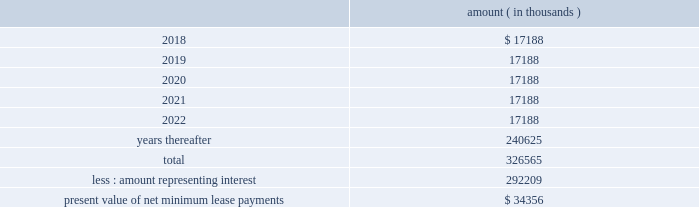As of december a031 , 2017 , system energy , in connection with the grand gulf sale and leaseback transactions , had future minimum lease payments ( reflecting an implicit rate of 5.13% ( 5.13 % ) ) that are recorded as long-term debt , as follows : amount ( in thousands ) .
Entergy corporation and subsidiaries notes to financial statements note 11 . a0 retirement , other postretirement benefits , and defined contribution plans a0 a0 ( entergy corporation , entergy arkansas , entergy louisiana , entergy mississippi , entergy new orleans , entergy texas , and system energy ) qualified pension plans entergy has eight qualified pension plans covering substantially all employees .
The entergy corporation retirement plan for non-bargaining employees ( non-bargaining plan i ) , the entergy corporation retirement plan for bargaining employees ( bargaining plan i ) , the entergy corporation retirement plan ii for non-bargaining employees ( non-bargaining plan ii ) , the entergy corporation retirement plan ii for bargaining employees , the entergy corporation retirement plan iii , and the entergy corporation retirement plan iv for bargaining employees a0are non-contributory final average pay plans and provide pension benefits that are based on employees 2019 credited service and compensation during employment .
Effective as of the close of business on december 31 , 2016 , the entergy corporation retirement plan iv for non-bargaining employees ( non-bargaining plan iv ) was merged with and into non-bargaining plan ii .
At the close of business on december 31 , 2016 , the liabilities for the accrued benefits and the assets attributable to such liabilities of all participants in non-bargaining plan iv were assumed by and transferred to non-bargaining plan ii .
There was no loss of vesting or benefit options or reduction of accrued benefits to affected participants as a result of this plan merger .
Non-bargaining employees whose most recent date of hire is after june 30 , 2014 participate in the entergy corporation cash balance plan for non-bargaining employees ( non-bargaining cash balance plan ) .
Certain bargaining employees hired or rehired after june 30 , 2014 , or such later date provided for in their applicable collective bargaining agreements , participate in the entergy corporation cash balance plan for bargaining employees ( bargaining cash balance plan ) .
The registrant subsidiaries participate in these four plans : non-bargaining plan i , bargaining plan i , non-bargaining cash balance plan , and bargaining cash balance plan .
The assets of the six final average pay qualified pension plans are held in a master trust established by entergy , and the assets of the two cash balance pension plans are held in a second master trust established by entergy . a0 a0each pension plan has an undivided beneficial interest in each of the investment accounts in its respective master trust that is maintained by a trustee . a0 a0use of the master trusts permits the commingling of the trust assets of the pension plans of entergy corporation and its registrant subsidiaries for investment and administrative purposes . a0 a0although assets in the master trusts are commingled , the trustee maintains supporting records for the purpose of allocating the trust level equity in net earnings ( loss ) and the administrative expenses of the investment accounts in each trust to the various participating pension plans in that particular trust . a0 a0the fair value of the trusts 2019 assets is determined by the trustee and certain investment managers . a0 a0for each trust , the trustee calculates a daily earnings factor , including realized and .
What are the minimum lease payments in 2022 as a percentage of the present value of net minimum lease payments? 
Computations: (17188 / 34356)
Answer: 0.50029. As of december a031 , 2017 , system energy , in connection with the grand gulf sale and leaseback transactions , had future minimum lease payments ( reflecting an implicit rate of 5.13% ( 5.13 % ) ) that are recorded as long-term debt , as follows : amount ( in thousands ) .
Entergy corporation and subsidiaries notes to financial statements note 11 . a0 retirement , other postretirement benefits , and defined contribution plans a0 a0 ( entergy corporation , entergy arkansas , entergy louisiana , entergy mississippi , entergy new orleans , entergy texas , and system energy ) qualified pension plans entergy has eight qualified pension plans covering substantially all employees .
The entergy corporation retirement plan for non-bargaining employees ( non-bargaining plan i ) , the entergy corporation retirement plan for bargaining employees ( bargaining plan i ) , the entergy corporation retirement plan ii for non-bargaining employees ( non-bargaining plan ii ) , the entergy corporation retirement plan ii for bargaining employees , the entergy corporation retirement plan iii , and the entergy corporation retirement plan iv for bargaining employees a0are non-contributory final average pay plans and provide pension benefits that are based on employees 2019 credited service and compensation during employment .
Effective as of the close of business on december 31 , 2016 , the entergy corporation retirement plan iv for non-bargaining employees ( non-bargaining plan iv ) was merged with and into non-bargaining plan ii .
At the close of business on december 31 , 2016 , the liabilities for the accrued benefits and the assets attributable to such liabilities of all participants in non-bargaining plan iv were assumed by and transferred to non-bargaining plan ii .
There was no loss of vesting or benefit options or reduction of accrued benefits to affected participants as a result of this plan merger .
Non-bargaining employees whose most recent date of hire is after june 30 , 2014 participate in the entergy corporation cash balance plan for non-bargaining employees ( non-bargaining cash balance plan ) .
Certain bargaining employees hired or rehired after june 30 , 2014 , or such later date provided for in their applicable collective bargaining agreements , participate in the entergy corporation cash balance plan for bargaining employees ( bargaining cash balance plan ) .
The registrant subsidiaries participate in these four plans : non-bargaining plan i , bargaining plan i , non-bargaining cash balance plan , and bargaining cash balance plan .
The assets of the six final average pay qualified pension plans are held in a master trust established by entergy , and the assets of the two cash balance pension plans are held in a second master trust established by entergy . a0 a0each pension plan has an undivided beneficial interest in each of the investment accounts in its respective master trust that is maintained by a trustee . a0 a0use of the master trusts permits the commingling of the trust assets of the pension plans of entergy corporation and its registrant subsidiaries for investment and administrative purposes . a0 a0although assets in the master trusts are commingled , the trustee maintains supporting records for the purpose of allocating the trust level equity in net earnings ( loss ) and the administrative expenses of the investment accounts in each trust to the various participating pension plans in that particular trust . a0 a0the fair value of the trusts 2019 assets is determined by the trustee and certain investment managers . a0 a0for each trust , the trustee calculates a daily earnings factor , including realized and .
What portion of the future minimum lease payments is due within the next 12 months? 
Computations: (17188 / 326565)
Answer: 0.05263. As of december a031 , 2017 , system energy , in connection with the grand gulf sale and leaseback transactions , had future minimum lease payments ( reflecting an implicit rate of 5.13% ( 5.13 % ) ) that are recorded as long-term debt , as follows : amount ( in thousands ) .
Entergy corporation and subsidiaries notes to financial statements note 11 . a0 retirement , other postretirement benefits , and defined contribution plans a0 a0 ( entergy corporation , entergy arkansas , entergy louisiana , entergy mississippi , entergy new orleans , entergy texas , and system energy ) qualified pension plans entergy has eight qualified pension plans covering substantially all employees .
The entergy corporation retirement plan for non-bargaining employees ( non-bargaining plan i ) , the entergy corporation retirement plan for bargaining employees ( bargaining plan i ) , the entergy corporation retirement plan ii for non-bargaining employees ( non-bargaining plan ii ) , the entergy corporation retirement plan ii for bargaining employees , the entergy corporation retirement plan iii , and the entergy corporation retirement plan iv for bargaining employees a0are non-contributory final average pay plans and provide pension benefits that are based on employees 2019 credited service and compensation during employment .
Effective as of the close of business on december 31 , 2016 , the entergy corporation retirement plan iv for non-bargaining employees ( non-bargaining plan iv ) was merged with and into non-bargaining plan ii .
At the close of business on december 31 , 2016 , the liabilities for the accrued benefits and the assets attributable to such liabilities of all participants in non-bargaining plan iv were assumed by and transferred to non-bargaining plan ii .
There was no loss of vesting or benefit options or reduction of accrued benefits to affected participants as a result of this plan merger .
Non-bargaining employees whose most recent date of hire is after june 30 , 2014 participate in the entergy corporation cash balance plan for non-bargaining employees ( non-bargaining cash balance plan ) .
Certain bargaining employees hired or rehired after june 30 , 2014 , or such later date provided for in their applicable collective bargaining agreements , participate in the entergy corporation cash balance plan for bargaining employees ( bargaining cash balance plan ) .
The registrant subsidiaries participate in these four plans : non-bargaining plan i , bargaining plan i , non-bargaining cash balance plan , and bargaining cash balance plan .
The assets of the six final average pay qualified pension plans are held in a master trust established by entergy , and the assets of the two cash balance pension plans are held in a second master trust established by entergy . a0 a0each pension plan has an undivided beneficial interest in each of the investment accounts in its respective master trust that is maintained by a trustee . a0 a0use of the master trusts permits the commingling of the trust assets of the pension plans of entergy corporation and its registrant subsidiaries for investment and administrative purposes . a0 a0although assets in the master trusts are commingled , the trustee maintains supporting records for the purpose of allocating the trust level equity in net earnings ( loss ) and the administrative expenses of the investment accounts in each trust to the various participating pension plans in that particular trust . a0 a0the fair value of the trusts 2019 assets is determined by the trustee and certain investment managers . a0 a0for each trust , the trustee calculates a daily earnings factor , including realized and .
What portion of the total future minimum lease payments is dedicated to interest payments? 
Computations: (292209 / 326565)
Answer: 0.8948. 